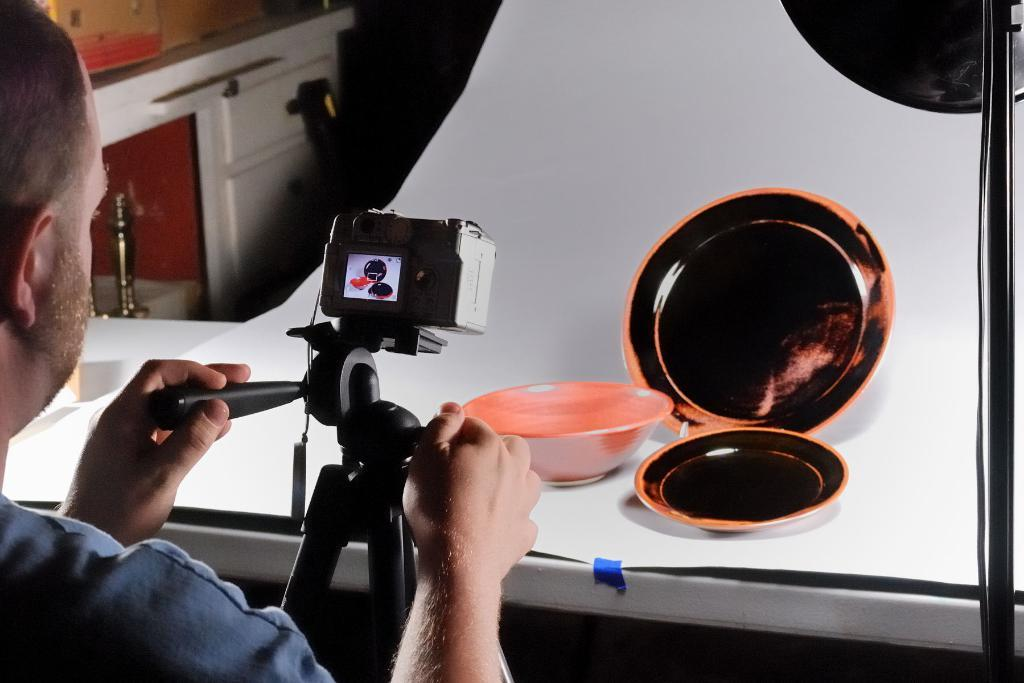What is the man holding in the image? The man is holding a camera with a stand. What type of dishware can be seen in the image? There is a bowl and plates in the image. What is stored on the cupboard in the image? There are boxes on a cupboard in the image. On what surface are the items placed? There is a surface where the items are placed. What type of cars are being traded in the image? There are no cars or trading activities depicted in the image. 